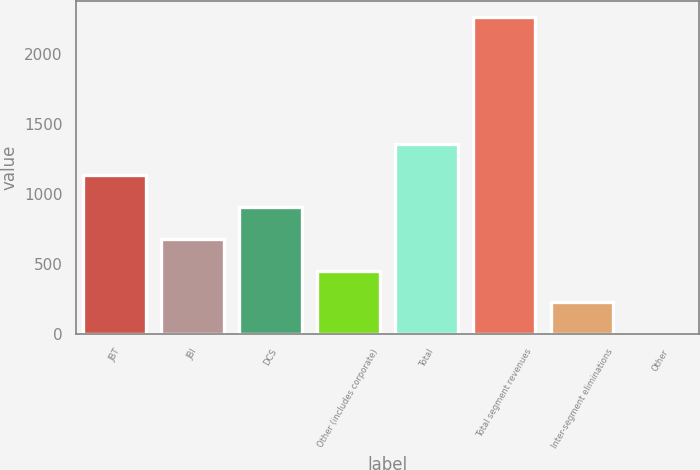Convert chart. <chart><loc_0><loc_0><loc_500><loc_500><bar_chart><fcel>JBT<fcel>JBI<fcel>DCS<fcel>Other (includes corporate)<fcel>Total<fcel>Total segment revenues<fcel>Inter-segment eliminations<fcel>Other<nl><fcel>1132.5<fcel>679.9<fcel>906.2<fcel>453.6<fcel>1358.8<fcel>2264<fcel>227.3<fcel>1<nl></chart> 